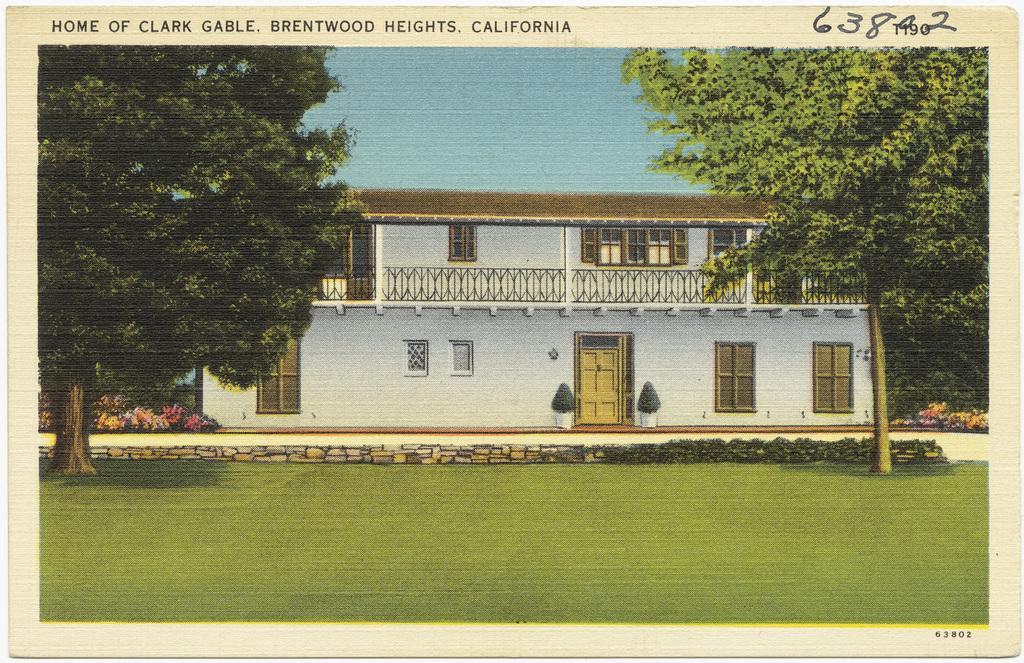In one or two sentences, can you explain what this image depicts? This is a picture of the painting. At the bottom, we see the grass. On either side of the picture, we see the trees. In the middle, we see a building in white color with a brown color roof. It has a railing, windows and a door. On the left side, we see the plants which have flowers. These flowers are in yellow, pink and white color. At the top, we see the sky. This picture might be a photo frame. 